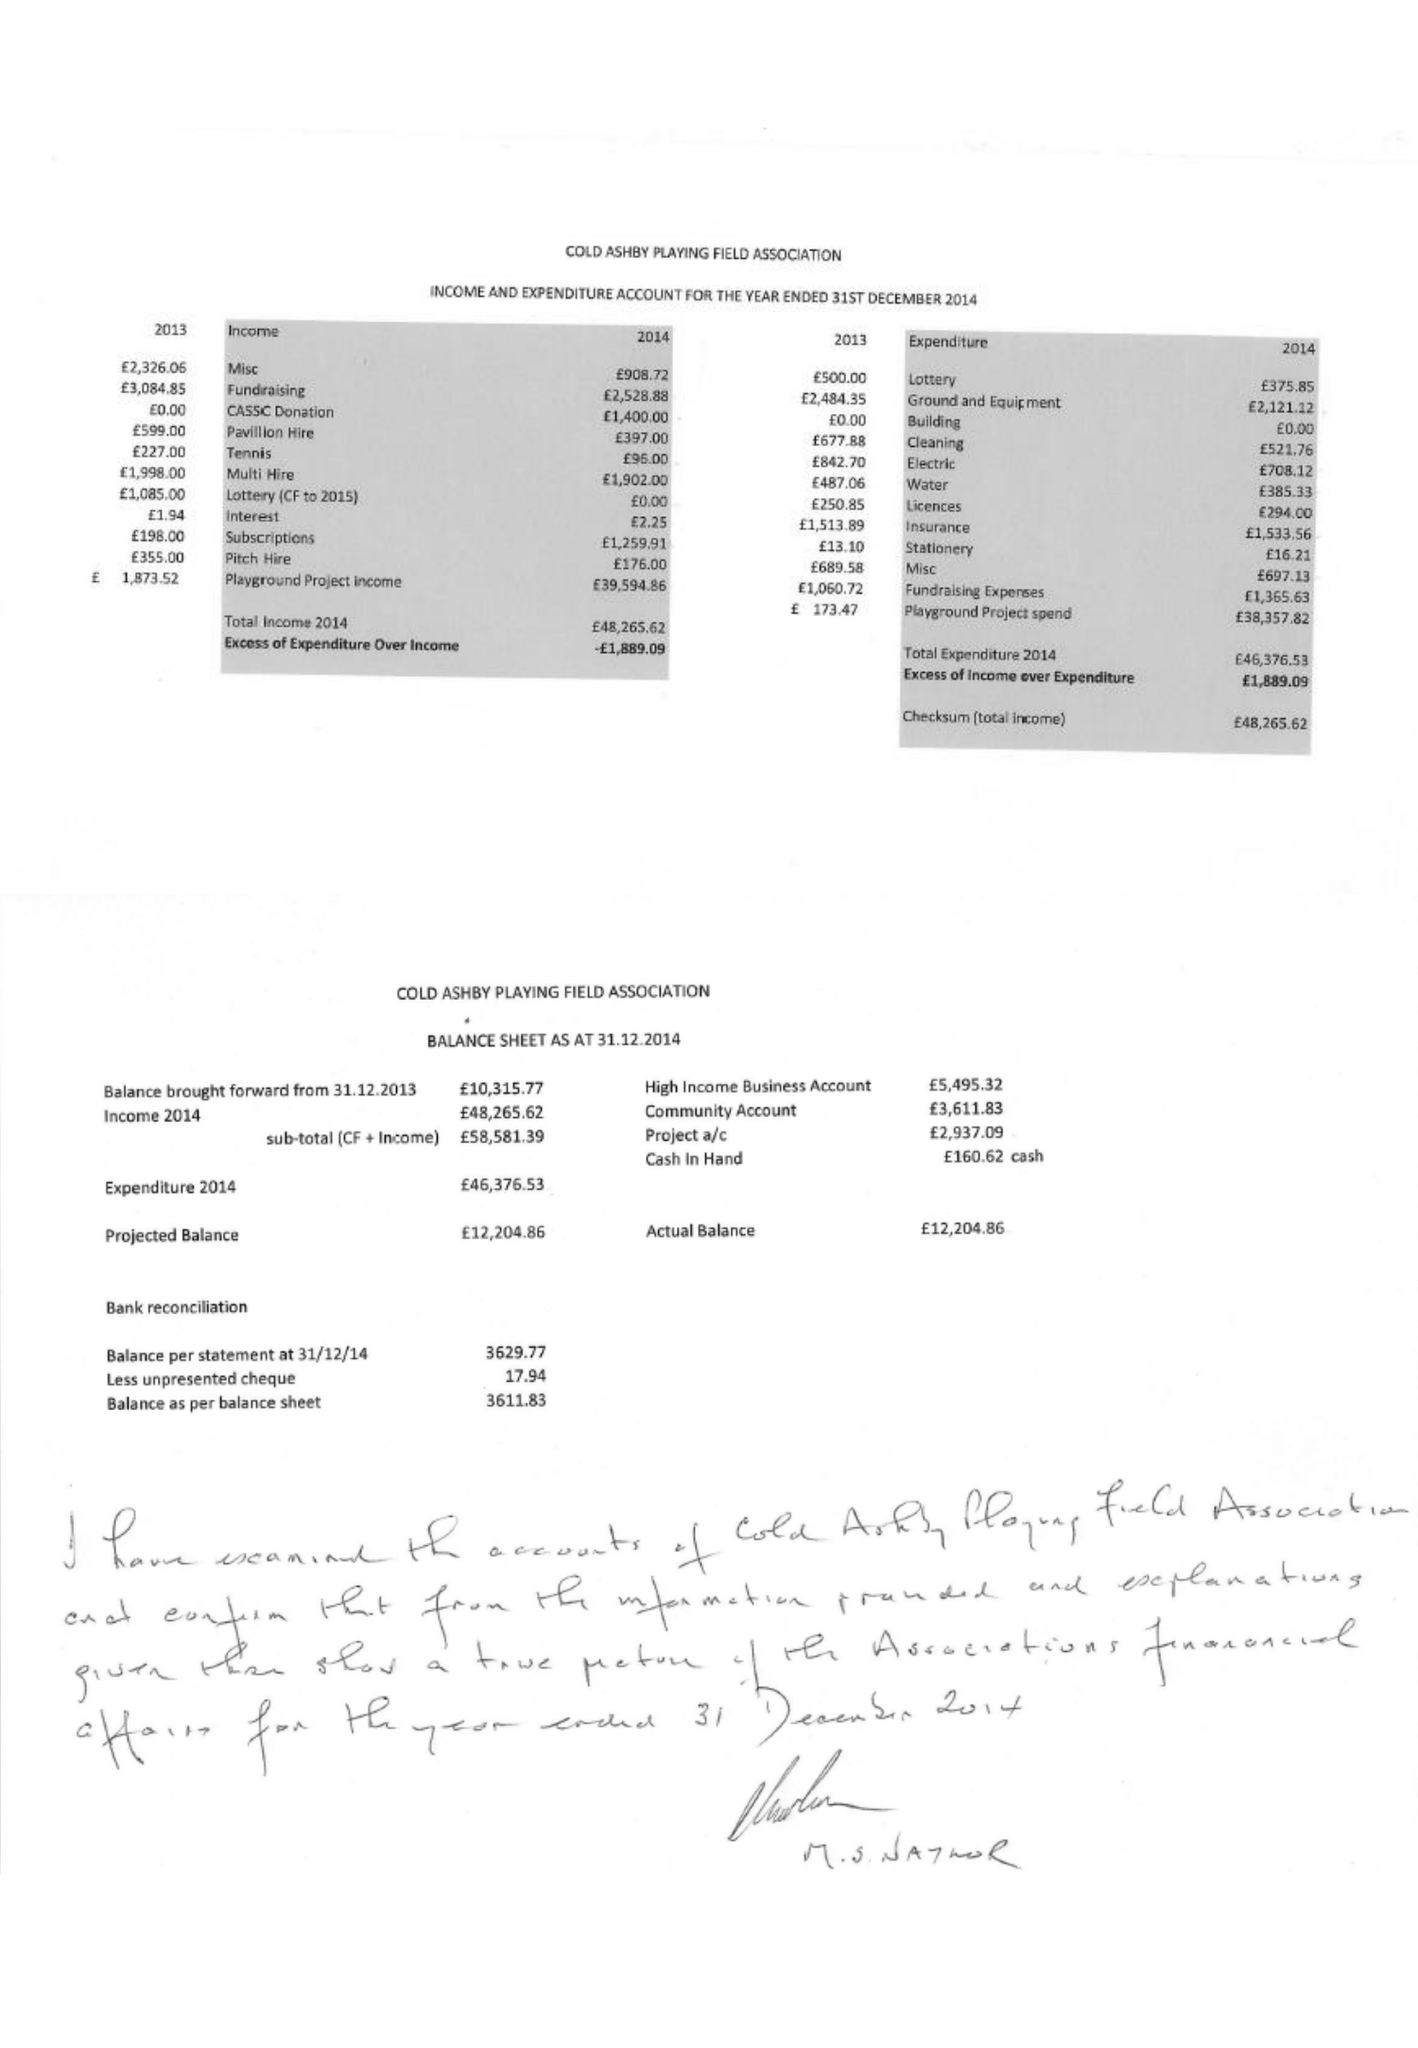What is the value for the income_annually_in_british_pounds?
Answer the question using a single word or phrase. 48266.00 